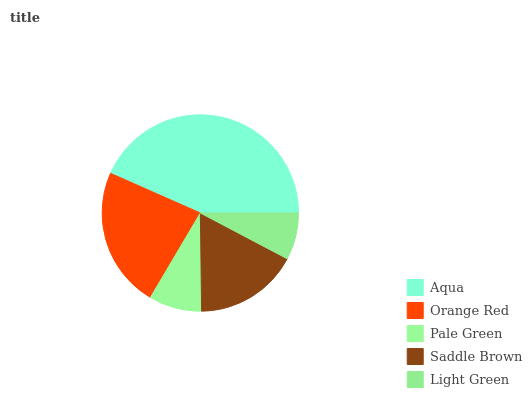Is Light Green the minimum?
Answer yes or no. Yes. Is Aqua the maximum?
Answer yes or no. Yes. Is Orange Red the minimum?
Answer yes or no. No. Is Orange Red the maximum?
Answer yes or no. No. Is Aqua greater than Orange Red?
Answer yes or no. Yes. Is Orange Red less than Aqua?
Answer yes or no. Yes. Is Orange Red greater than Aqua?
Answer yes or no. No. Is Aqua less than Orange Red?
Answer yes or no. No. Is Saddle Brown the high median?
Answer yes or no. Yes. Is Saddle Brown the low median?
Answer yes or no. Yes. Is Pale Green the high median?
Answer yes or no. No. Is Pale Green the low median?
Answer yes or no. No. 